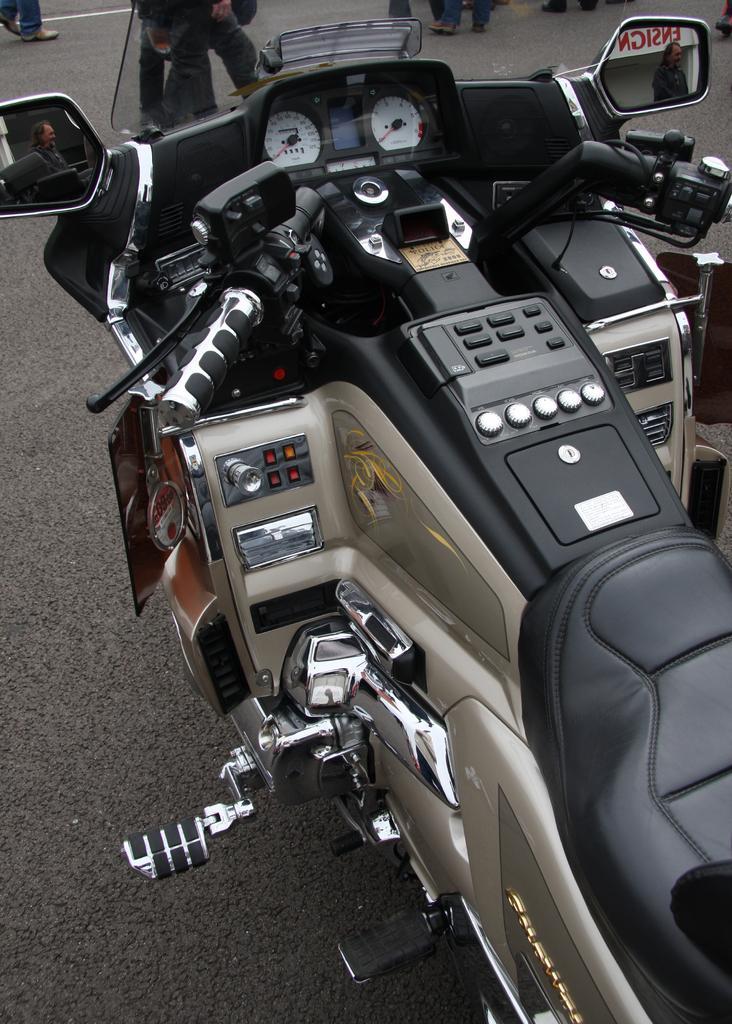How would you summarize this image in a sentence or two? We can see bike on the road and we can see side mirrors, through this side mirrors we can see people. Background we can see person's legs. 